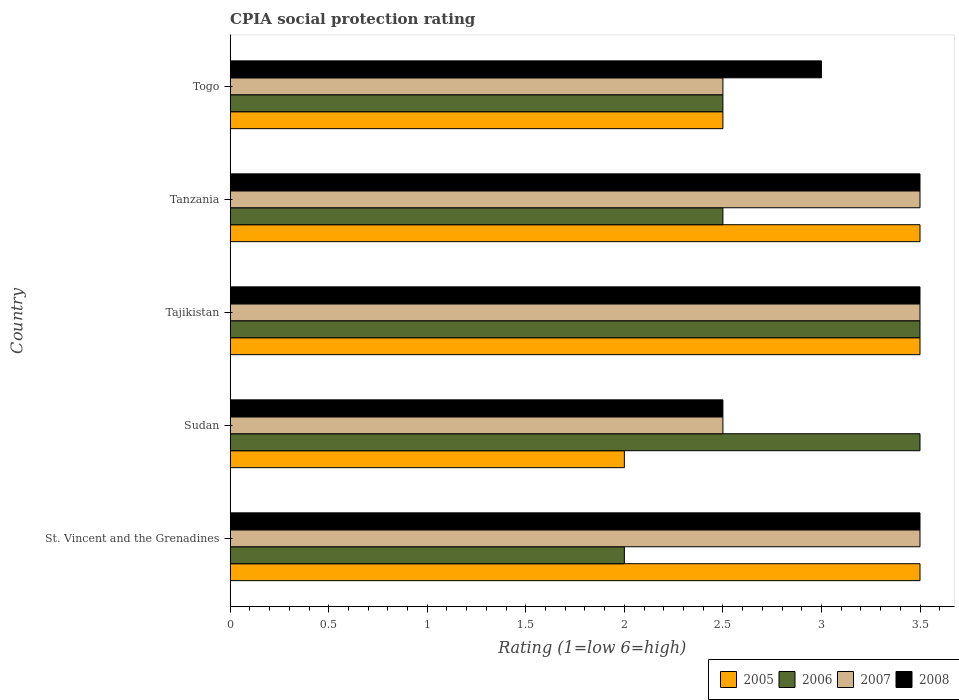How many different coloured bars are there?
Keep it short and to the point. 4. Are the number of bars per tick equal to the number of legend labels?
Offer a very short reply. Yes. Are the number of bars on each tick of the Y-axis equal?
Keep it short and to the point. Yes. How many bars are there on the 2nd tick from the top?
Give a very brief answer. 4. How many bars are there on the 4th tick from the bottom?
Provide a short and direct response. 4. What is the label of the 5th group of bars from the top?
Your answer should be very brief. St. Vincent and the Grenadines. In how many cases, is the number of bars for a given country not equal to the number of legend labels?
Your response must be concise. 0. What is the CPIA rating in 2008 in Sudan?
Provide a succinct answer. 2.5. In which country was the CPIA rating in 2006 maximum?
Offer a very short reply. Sudan. In which country was the CPIA rating in 2005 minimum?
Give a very brief answer. Sudan. What is the total CPIA rating in 2005 in the graph?
Your response must be concise. 15. What is the difference between the CPIA rating in 2006 in Sudan and the CPIA rating in 2007 in St. Vincent and the Grenadines?
Make the answer very short. 0. What is the average CPIA rating in 2008 per country?
Your response must be concise. 3.2. What is the difference between the CPIA rating in 2008 and CPIA rating in 2007 in St. Vincent and the Grenadines?
Make the answer very short. 0. In how many countries, is the CPIA rating in 2006 greater than 0.8 ?
Ensure brevity in your answer.  5. What is the ratio of the CPIA rating in 2007 in Sudan to that in Tanzania?
Make the answer very short. 0.71. What is the difference between the highest and the lowest CPIA rating in 2008?
Give a very brief answer. 1. Is the sum of the CPIA rating in 2008 in St. Vincent and the Grenadines and Tajikistan greater than the maximum CPIA rating in 2005 across all countries?
Give a very brief answer. Yes. Is it the case that in every country, the sum of the CPIA rating in 2008 and CPIA rating in 2007 is greater than the sum of CPIA rating in 2006 and CPIA rating in 2005?
Your answer should be very brief. No. Is it the case that in every country, the sum of the CPIA rating in 2007 and CPIA rating in 2006 is greater than the CPIA rating in 2008?
Make the answer very short. Yes. Are the values on the major ticks of X-axis written in scientific E-notation?
Ensure brevity in your answer.  No. Does the graph contain any zero values?
Ensure brevity in your answer.  No. Where does the legend appear in the graph?
Your answer should be compact. Bottom right. How are the legend labels stacked?
Provide a succinct answer. Horizontal. What is the title of the graph?
Your response must be concise. CPIA social protection rating. Does "1972" appear as one of the legend labels in the graph?
Make the answer very short. No. What is the label or title of the X-axis?
Provide a succinct answer. Rating (1=low 6=high). What is the Rating (1=low 6=high) in 2005 in St. Vincent and the Grenadines?
Ensure brevity in your answer.  3.5. What is the Rating (1=low 6=high) in 2006 in St. Vincent and the Grenadines?
Offer a very short reply. 2. What is the Rating (1=low 6=high) of 2007 in St. Vincent and the Grenadines?
Your response must be concise. 3.5. What is the Rating (1=low 6=high) in 2005 in Sudan?
Make the answer very short. 2. What is the Rating (1=low 6=high) in 2006 in Sudan?
Provide a succinct answer. 3.5. What is the Rating (1=low 6=high) in 2006 in Tajikistan?
Ensure brevity in your answer.  3.5. What is the Rating (1=low 6=high) of 2005 in Tanzania?
Offer a very short reply. 3.5. What is the Rating (1=low 6=high) in 2008 in Tanzania?
Offer a very short reply. 3.5. What is the Rating (1=low 6=high) of 2006 in Togo?
Keep it short and to the point. 2.5. What is the Rating (1=low 6=high) in 2008 in Togo?
Ensure brevity in your answer.  3. Across all countries, what is the maximum Rating (1=low 6=high) in 2005?
Offer a very short reply. 3.5. What is the total Rating (1=low 6=high) of 2005 in the graph?
Provide a succinct answer. 15. What is the total Rating (1=low 6=high) in 2008 in the graph?
Give a very brief answer. 16. What is the difference between the Rating (1=low 6=high) of 2008 in St. Vincent and the Grenadines and that in Sudan?
Ensure brevity in your answer.  1. What is the difference between the Rating (1=low 6=high) of 2005 in St. Vincent and the Grenadines and that in Tajikistan?
Offer a terse response. 0. What is the difference between the Rating (1=low 6=high) of 2006 in St. Vincent and the Grenadines and that in Tajikistan?
Ensure brevity in your answer.  -1.5. What is the difference between the Rating (1=low 6=high) of 2007 in St. Vincent and the Grenadines and that in Togo?
Your answer should be very brief. 1. What is the difference between the Rating (1=low 6=high) in 2008 in St. Vincent and the Grenadines and that in Togo?
Offer a terse response. 0.5. What is the difference between the Rating (1=low 6=high) in 2006 in Sudan and that in Tajikistan?
Make the answer very short. 0. What is the difference between the Rating (1=low 6=high) of 2007 in Sudan and that in Tajikistan?
Give a very brief answer. -1. What is the difference between the Rating (1=low 6=high) in 2008 in Sudan and that in Tajikistan?
Your answer should be very brief. -1. What is the difference between the Rating (1=low 6=high) in 2005 in Sudan and that in Tanzania?
Ensure brevity in your answer.  -1.5. What is the difference between the Rating (1=low 6=high) of 2006 in Sudan and that in Tanzania?
Keep it short and to the point. 1. What is the difference between the Rating (1=low 6=high) of 2007 in Sudan and that in Tanzania?
Offer a terse response. -1. What is the difference between the Rating (1=low 6=high) in 2008 in Sudan and that in Tanzania?
Your answer should be compact. -1. What is the difference between the Rating (1=low 6=high) in 2005 in Sudan and that in Togo?
Keep it short and to the point. -0.5. What is the difference between the Rating (1=low 6=high) in 2007 in Sudan and that in Togo?
Give a very brief answer. 0. What is the difference between the Rating (1=low 6=high) in 2008 in Sudan and that in Togo?
Ensure brevity in your answer.  -0.5. What is the difference between the Rating (1=low 6=high) in 2006 in Tajikistan and that in Tanzania?
Ensure brevity in your answer.  1. What is the difference between the Rating (1=low 6=high) in 2007 in Tajikistan and that in Tanzania?
Give a very brief answer. 0. What is the difference between the Rating (1=low 6=high) of 2008 in Tajikistan and that in Tanzania?
Make the answer very short. 0. What is the difference between the Rating (1=low 6=high) in 2008 in Tajikistan and that in Togo?
Make the answer very short. 0.5. What is the difference between the Rating (1=low 6=high) of 2005 in Tanzania and that in Togo?
Your answer should be compact. 1. What is the difference between the Rating (1=low 6=high) in 2005 in St. Vincent and the Grenadines and the Rating (1=low 6=high) in 2006 in Sudan?
Your answer should be very brief. 0. What is the difference between the Rating (1=low 6=high) in 2005 in St. Vincent and the Grenadines and the Rating (1=low 6=high) in 2007 in Sudan?
Give a very brief answer. 1. What is the difference between the Rating (1=low 6=high) of 2005 in St. Vincent and the Grenadines and the Rating (1=low 6=high) of 2008 in Sudan?
Provide a short and direct response. 1. What is the difference between the Rating (1=low 6=high) in 2006 in St. Vincent and the Grenadines and the Rating (1=low 6=high) in 2007 in Sudan?
Your answer should be very brief. -0.5. What is the difference between the Rating (1=low 6=high) of 2007 in St. Vincent and the Grenadines and the Rating (1=low 6=high) of 2008 in Sudan?
Provide a succinct answer. 1. What is the difference between the Rating (1=low 6=high) of 2005 in St. Vincent and the Grenadines and the Rating (1=low 6=high) of 2006 in Tajikistan?
Ensure brevity in your answer.  0. What is the difference between the Rating (1=low 6=high) of 2005 in St. Vincent and the Grenadines and the Rating (1=low 6=high) of 2007 in Tajikistan?
Provide a succinct answer. 0. What is the difference between the Rating (1=low 6=high) of 2005 in St. Vincent and the Grenadines and the Rating (1=low 6=high) of 2008 in Tajikistan?
Make the answer very short. 0. What is the difference between the Rating (1=low 6=high) of 2006 in St. Vincent and the Grenadines and the Rating (1=low 6=high) of 2007 in Tajikistan?
Offer a very short reply. -1.5. What is the difference between the Rating (1=low 6=high) of 2006 in St. Vincent and the Grenadines and the Rating (1=low 6=high) of 2008 in Tajikistan?
Offer a terse response. -1.5. What is the difference between the Rating (1=low 6=high) of 2005 in St. Vincent and the Grenadines and the Rating (1=low 6=high) of 2007 in Tanzania?
Give a very brief answer. 0. What is the difference between the Rating (1=low 6=high) of 2006 in St. Vincent and the Grenadines and the Rating (1=low 6=high) of 2008 in Tanzania?
Provide a succinct answer. -1.5. What is the difference between the Rating (1=low 6=high) in 2005 in St. Vincent and the Grenadines and the Rating (1=low 6=high) in 2007 in Togo?
Ensure brevity in your answer.  1. What is the difference between the Rating (1=low 6=high) of 2005 in St. Vincent and the Grenadines and the Rating (1=low 6=high) of 2008 in Togo?
Offer a terse response. 0.5. What is the difference between the Rating (1=low 6=high) in 2006 in St. Vincent and the Grenadines and the Rating (1=low 6=high) in 2007 in Togo?
Your answer should be very brief. -0.5. What is the difference between the Rating (1=low 6=high) of 2006 in St. Vincent and the Grenadines and the Rating (1=low 6=high) of 2008 in Togo?
Offer a terse response. -1. What is the difference between the Rating (1=low 6=high) in 2007 in St. Vincent and the Grenadines and the Rating (1=low 6=high) in 2008 in Togo?
Keep it short and to the point. 0.5. What is the difference between the Rating (1=low 6=high) in 2005 in Sudan and the Rating (1=low 6=high) in 2006 in Tajikistan?
Provide a short and direct response. -1.5. What is the difference between the Rating (1=low 6=high) of 2005 in Sudan and the Rating (1=low 6=high) of 2007 in Tajikistan?
Ensure brevity in your answer.  -1.5. What is the difference between the Rating (1=low 6=high) of 2005 in Sudan and the Rating (1=low 6=high) of 2007 in Togo?
Provide a succinct answer. -0.5. What is the difference between the Rating (1=low 6=high) of 2005 in Tajikistan and the Rating (1=low 6=high) of 2008 in Tanzania?
Offer a very short reply. 0. What is the difference between the Rating (1=low 6=high) of 2007 in Tajikistan and the Rating (1=low 6=high) of 2008 in Tanzania?
Provide a short and direct response. 0. What is the difference between the Rating (1=low 6=high) in 2005 in Tajikistan and the Rating (1=low 6=high) in 2006 in Togo?
Provide a short and direct response. 1. What is the difference between the Rating (1=low 6=high) of 2005 in Tajikistan and the Rating (1=low 6=high) of 2007 in Togo?
Give a very brief answer. 1. What is the difference between the Rating (1=low 6=high) in 2006 in Tajikistan and the Rating (1=low 6=high) in 2007 in Togo?
Provide a succinct answer. 1. What is the difference between the Rating (1=low 6=high) in 2007 in Tajikistan and the Rating (1=low 6=high) in 2008 in Togo?
Give a very brief answer. 0.5. What is the difference between the Rating (1=low 6=high) in 2006 in Tanzania and the Rating (1=low 6=high) in 2007 in Togo?
Offer a very short reply. 0. What is the difference between the Rating (1=low 6=high) of 2006 in Tanzania and the Rating (1=low 6=high) of 2008 in Togo?
Provide a short and direct response. -0.5. What is the difference between the Rating (1=low 6=high) in 2007 in Tanzania and the Rating (1=low 6=high) in 2008 in Togo?
Provide a short and direct response. 0.5. What is the average Rating (1=low 6=high) in 2005 per country?
Your answer should be very brief. 3. What is the difference between the Rating (1=low 6=high) in 2005 and Rating (1=low 6=high) in 2006 in St. Vincent and the Grenadines?
Offer a very short reply. 1.5. What is the difference between the Rating (1=low 6=high) in 2007 and Rating (1=low 6=high) in 2008 in St. Vincent and the Grenadines?
Ensure brevity in your answer.  0. What is the difference between the Rating (1=low 6=high) of 2005 and Rating (1=low 6=high) of 2006 in Sudan?
Give a very brief answer. -1.5. What is the difference between the Rating (1=low 6=high) in 2005 and Rating (1=low 6=high) in 2007 in Sudan?
Provide a succinct answer. -0.5. What is the difference between the Rating (1=low 6=high) of 2005 and Rating (1=low 6=high) of 2008 in Sudan?
Make the answer very short. -0.5. What is the difference between the Rating (1=low 6=high) in 2006 and Rating (1=low 6=high) in 2008 in Sudan?
Make the answer very short. 1. What is the difference between the Rating (1=low 6=high) of 2005 and Rating (1=low 6=high) of 2006 in Tajikistan?
Offer a very short reply. 0. What is the difference between the Rating (1=low 6=high) in 2006 and Rating (1=low 6=high) in 2007 in Tajikistan?
Ensure brevity in your answer.  0. What is the difference between the Rating (1=low 6=high) of 2007 and Rating (1=low 6=high) of 2008 in Tajikistan?
Offer a very short reply. 0. What is the difference between the Rating (1=low 6=high) of 2005 and Rating (1=low 6=high) of 2006 in Tanzania?
Your answer should be very brief. 1. What is the difference between the Rating (1=low 6=high) of 2005 and Rating (1=low 6=high) of 2007 in Tanzania?
Offer a very short reply. 0. What is the difference between the Rating (1=low 6=high) of 2005 and Rating (1=low 6=high) of 2008 in Tanzania?
Provide a succinct answer. 0. What is the difference between the Rating (1=low 6=high) in 2006 and Rating (1=low 6=high) in 2007 in Tanzania?
Provide a short and direct response. -1. What is the difference between the Rating (1=low 6=high) of 2006 and Rating (1=low 6=high) of 2008 in Tanzania?
Your answer should be very brief. -1. What is the difference between the Rating (1=low 6=high) of 2007 and Rating (1=low 6=high) of 2008 in Tanzania?
Your answer should be very brief. 0. What is the difference between the Rating (1=low 6=high) in 2005 and Rating (1=low 6=high) in 2008 in Togo?
Your answer should be very brief. -0.5. What is the difference between the Rating (1=low 6=high) in 2006 and Rating (1=low 6=high) in 2008 in Togo?
Your answer should be very brief. -0.5. What is the ratio of the Rating (1=low 6=high) of 2005 in St. Vincent and the Grenadines to that in Sudan?
Provide a short and direct response. 1.75. What is the ratio of the Rating (1=low 6=high) in 2007 in St. Vincent and the Grenadines to that in Sudan?
Your answer should be compact. 1.4. What is the ratio of the Rating (1=low 6=high) of 2008 in St. Vincent and the Grenadines to that in Sudan?
Your answer should be very brief. 1.4. What is the ratio of the Rating (1=low 6=high) in 2007 in St. Vincent and the Grenadines to that in Tajikistan?
Offer a terse response. 1. What is the ratio of the Rating (1=low 6=high) in 2005 in St. Vincent and the Grenadines to that in Tanzania?
Your answer should be compact. 1. What is the ratio of the Rating (1=low 6=high) of 2006 in St. Vincent and the Grenadines to that in Tanzania?
Offer a terse response. 0.8. What is the ratio of the Rating (1=low 6=high) in 2008 in St. Vincent and the Grenadines to that in Tanzania?
Offer a very short reply. 1. What is the ratio of the Rating (1=low 6=high) of 2005 in St. Vincent and the Grenadines to that in Togo?
Provide a succinct answer. 1.4. What is the ratio of the Rating (1=low 6=high) of 2006 in St. Vincent and the Grenadines to that in Togo?
Your response must be concise. 0.8. What is the ratio of the Rating (1=low 6=high) in 2007 in St. Vincent and the Grenadines to that in Togo?
Offer a very short reply. 1.4. What is the ratio of the Rating (1=low 6=high) of 2008 in St. Vincent and the Grenadines to that in Togo?
Your answer should be compact. 1.17. What is the ratio of the Rating (1=low 6=high) in 2008 in Sudan to that in Tajikistan?
Make the answer very short. 0.71. What is the ratio of the Rating (1=low 6=high) in 2005 in Sudan to that in Tanzania?
Your response must be concise. 0.57. What is the ratio of the Rating (1=low 6=high) in 2007 in Sudan to that in Tanzania?
Offer a very short reply. 0.71. What is the ratio of the Rating (1=low 6=high) in 2005 in Sudan to that in Togo?
Provide a succinct answer. 0.8. What is the ratio of the Rating (1=low 6=high) in 2007 in Sudan to that in Togo?
Your answer should be compact. 1. What is the ratio of the Rating (1=low 6=high) in 2008 in Sudan to that in Togo?
Make the answer very short. 0.83. What is the ratio of the Rating (1=low 6=high) of 2005 in Tajikistan to that in Tanzania?
Make the answer very short. 1. What is the ratio of the Rating (1=low 6=high) of 2007 in Tajikistan to that in Tanzania?
Your response must be concise. 1. What is the ratio of the Rating (1=low 6=high) of 2005 in Tajikistan to that in Togo?
Keep it short and to the point. 1.4. What is the ratio of the Rating (1=low 6=high) in 2006 in Tajikistan to that in Togo?
Provide a short and direct response. 1.4. What is the ratio of the Rating (1=low 6=high) of 2007 in Tajikistan to that in Togo?
Your answer should be very brief. 1.4. What is the ratio of the Rating (1=low 6=high) of 2007 in Tanzania to that in Togo?
Your response must be concise. 1.4. What is the ratio of the Rating (1=low 6=high) in 2008 in Tanzania to that in Togo?
Provide a succinct answer. 1.17. What is the difference between the highest and the second highest Rating (1=low 6=high) of 2005?
Make the answer very short. 0. What is the difference between the highest and the second highest Rating (1=low 6=high) in 2006?
Offer a very short reply. 0. 